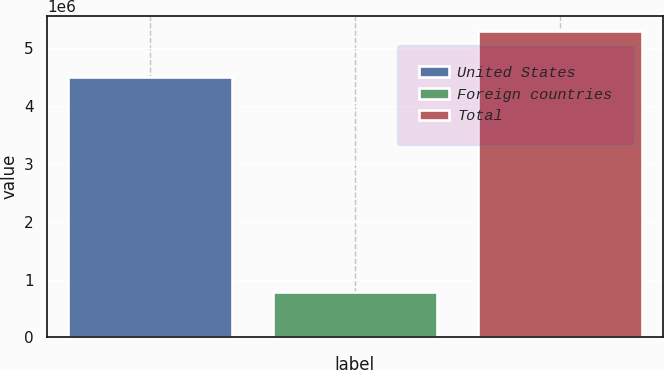<chart> <loc_0><loc_0><loc_500><loc_500><bar_chart><fcel>United States<fcel>Foreign countries<fcel>Total<nl><fcel>4.50129e+06<fcel>792959<fcel>5.29425e+06<nl></chart> 